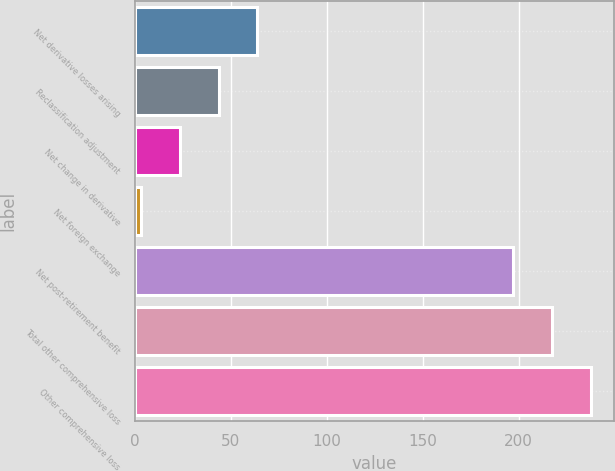<chart> <loc_0><loc_0><loc_500><loc_500><bar_chart><fcel>Net derivative losses arising<fcel>Reclassification adjustment<fcel>Net change in derivative<fcel>Net foreign exchange<fcel>Net post-retirement benefit<fcel>Total other comprehensive loss<fcel>Other comprehensive loss<nl><fcel>63.9<fcel>43.6<fcel>23.3<fcel>3<fcel>197<fcel>217.3<fcel>237.6<nl></chart> 